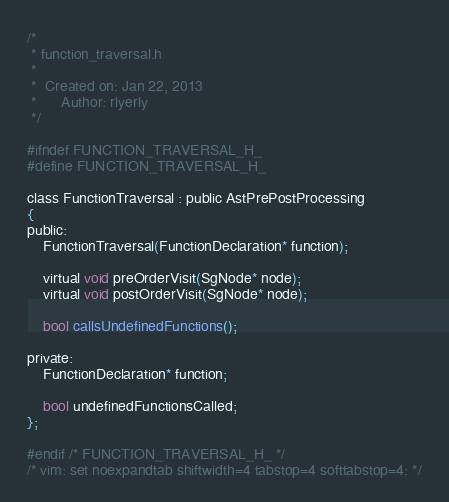Convert code to text. <code><loc_0><loc_0><loc_500><loc_500><_C_>/*
 * function_traversal.h
 *
 *  Created on: Jan 22, 2013
 *      Author: rlyerly
 */

#ifndef FUNCTION_TRAVERSAL_H_
#define FUNCTION_TRAVERSAL_H_

class FunctionTraversal : public AstPrePostProcessing
{
public:
	FunctionTraversal(FunctionDeclaration* function);

	virtual void preOrderVisit(SgNode* node);
	virtual void postOrderVisit(SgNode* node);

	bool callsUndefinedFunctions();

private:
	FunctionDeclaration* function;

	bool undefinedFunctionsCalled;
};

#endif /* FUNCTION_TRAVERSAL_H_ */
/* vim: set noexpandtab shiftwidth=4 tabstop=4 softtabstop=4: */
</code> 